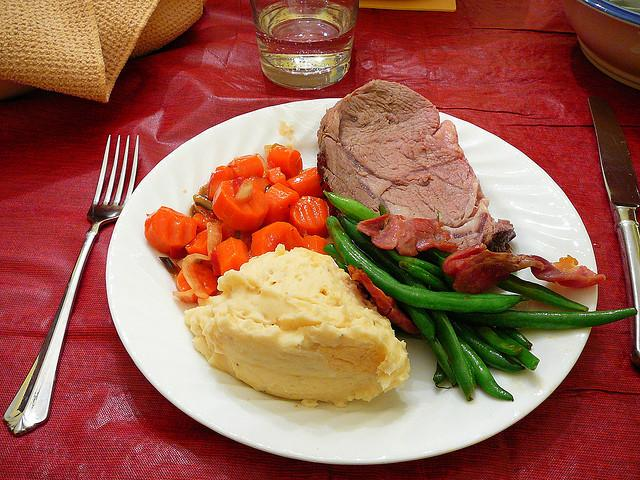What is a healthy item on the plate? carrots 